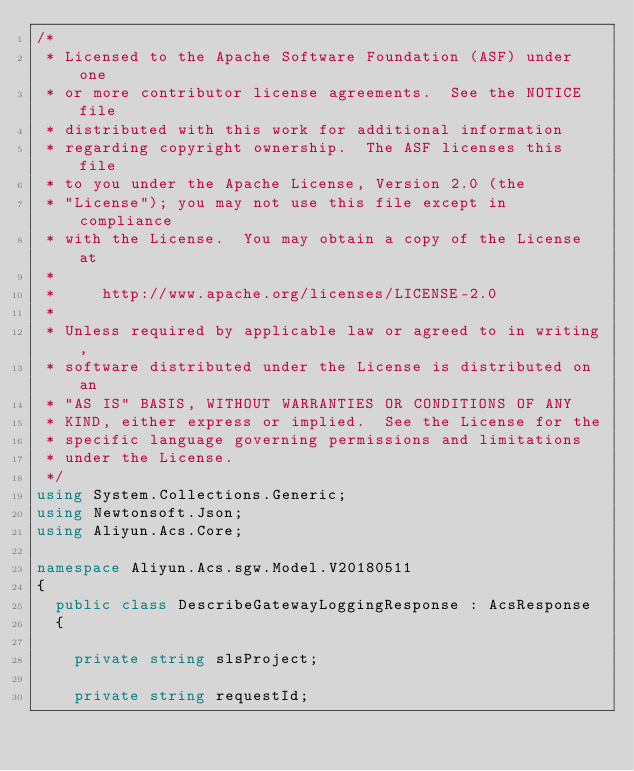<code> <loc_0><loc_0><loc_500><loc_500><_C#_>/*
 * Licensed to the Apache Software Foundation (ASF) under one
 * or more contributor license agreements.  See the NOTICE file
 * distributed with this work for additional information
 * regarding copyright ownership.  The ASF licenses this file
 * to you under the Apache License, Version 2.0 (the
 * "License"); you may not use this file except in compliance
 * with the License.  You may obtain a copy of the License at
 *
 *     http://www.apache.org/licenses/LICENSE-2.0
 *
 * Unless required by applicable law or agreed to in writing,
 * software distributed under the License is distributed on an
 * "AS IS" BASIS, WITHOUT WARRANTIES OR CONDITIONS OF ANY
 * KIND, either express or implied.  See the License for the
 * specific language governing permissions and limitations
 * under the License.
 */
using System.Collections.Generic;
using Newtonsoft.Json;
using Aliyun.Acs.Core;

namespace Aliyun.Acs.sgw.Model.V20180511
{
	public class DescribeGatewayLoggingResponse : AcsResponse
	{

		private string slsProject;

		private string requestId;
</code> 